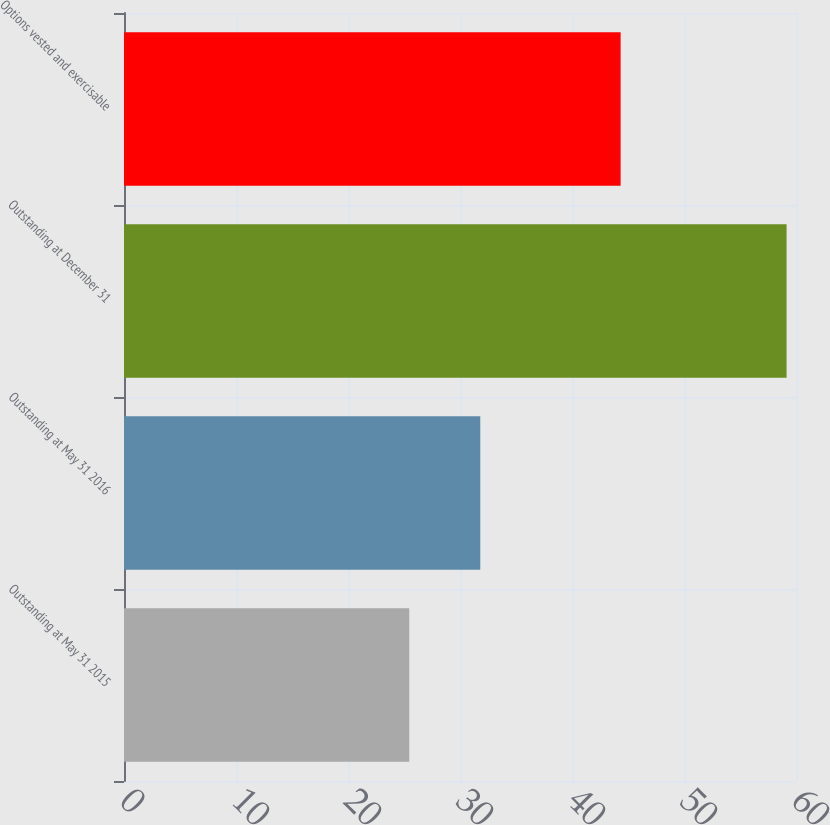<chart> <loc_0><loc_0><loc_500><loc_500><bar_chart><fcel>Outstanding at May 31 2015<fcel>Outstanding at May 31 2016<fcel>Outstanding at December 31<fcel>Options vested and exercisable<nl><fcel>25.47<fcel>31.81<fcel>59.16<fcel>44.34<nl></chart> 